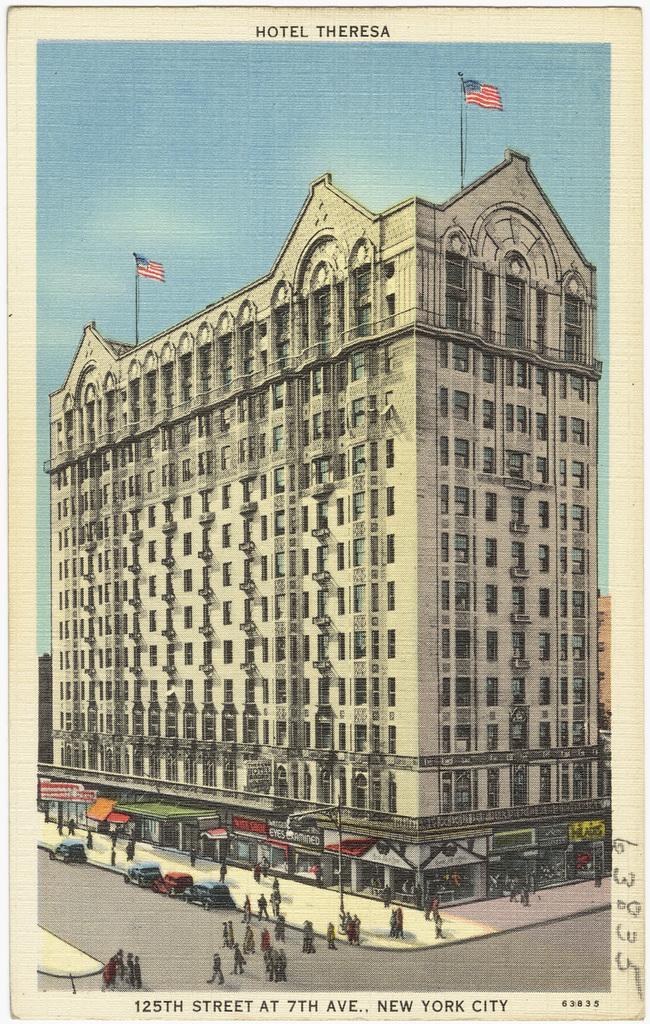How would you summarize this image in a sentence or two? In this picture we can see a group of people, vehicles on the road, some people on the footpath, name boards, flags, building with windows and some objects and in the background we can see the sky and at the top and bottom of this picture we can see some text. 